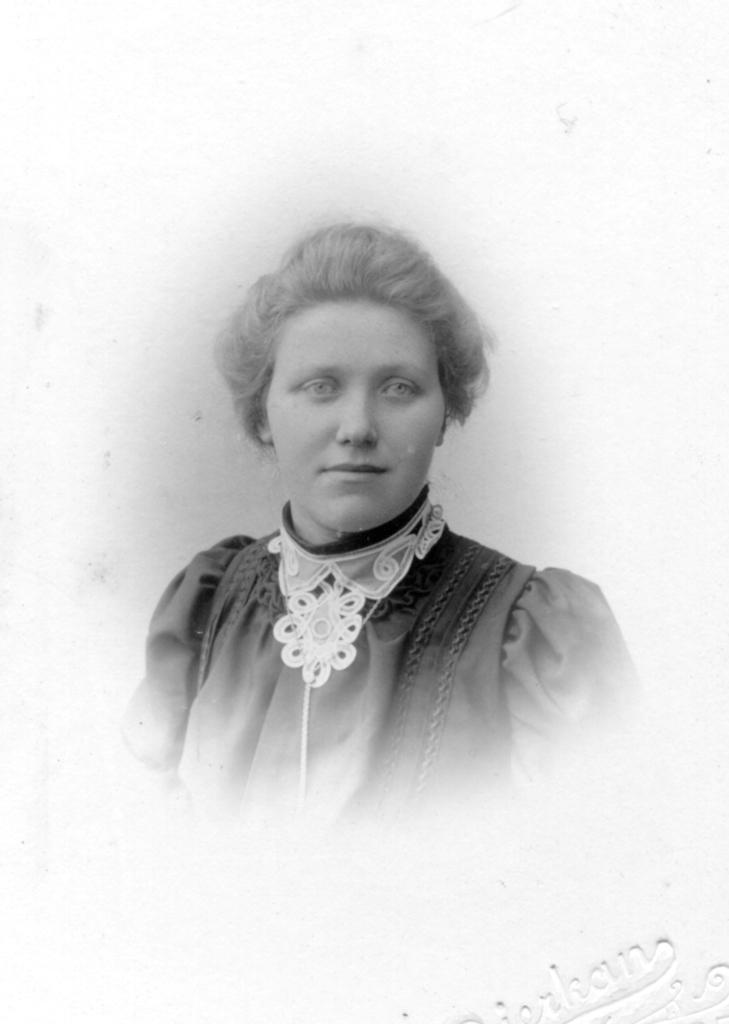Could you give a brief overview of what you see in this image? In this image I can see a woman, she wears the dress, this image is in black and white color. 